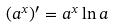<formula> <loc_0><loc_0><loc_500><loc_500>( a ^ { x } ) ^ { \prime } = a ^ { x } \ln a</formula> 